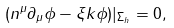Convert formula to latex. <formula><loc_0><loc_0><loc_500><loc_500>( n ^ { \mu } \partial _ { \mu } \phi - \xi k \phi ) | _ { \Sigma _ { h } } = 0 ,</formula> 